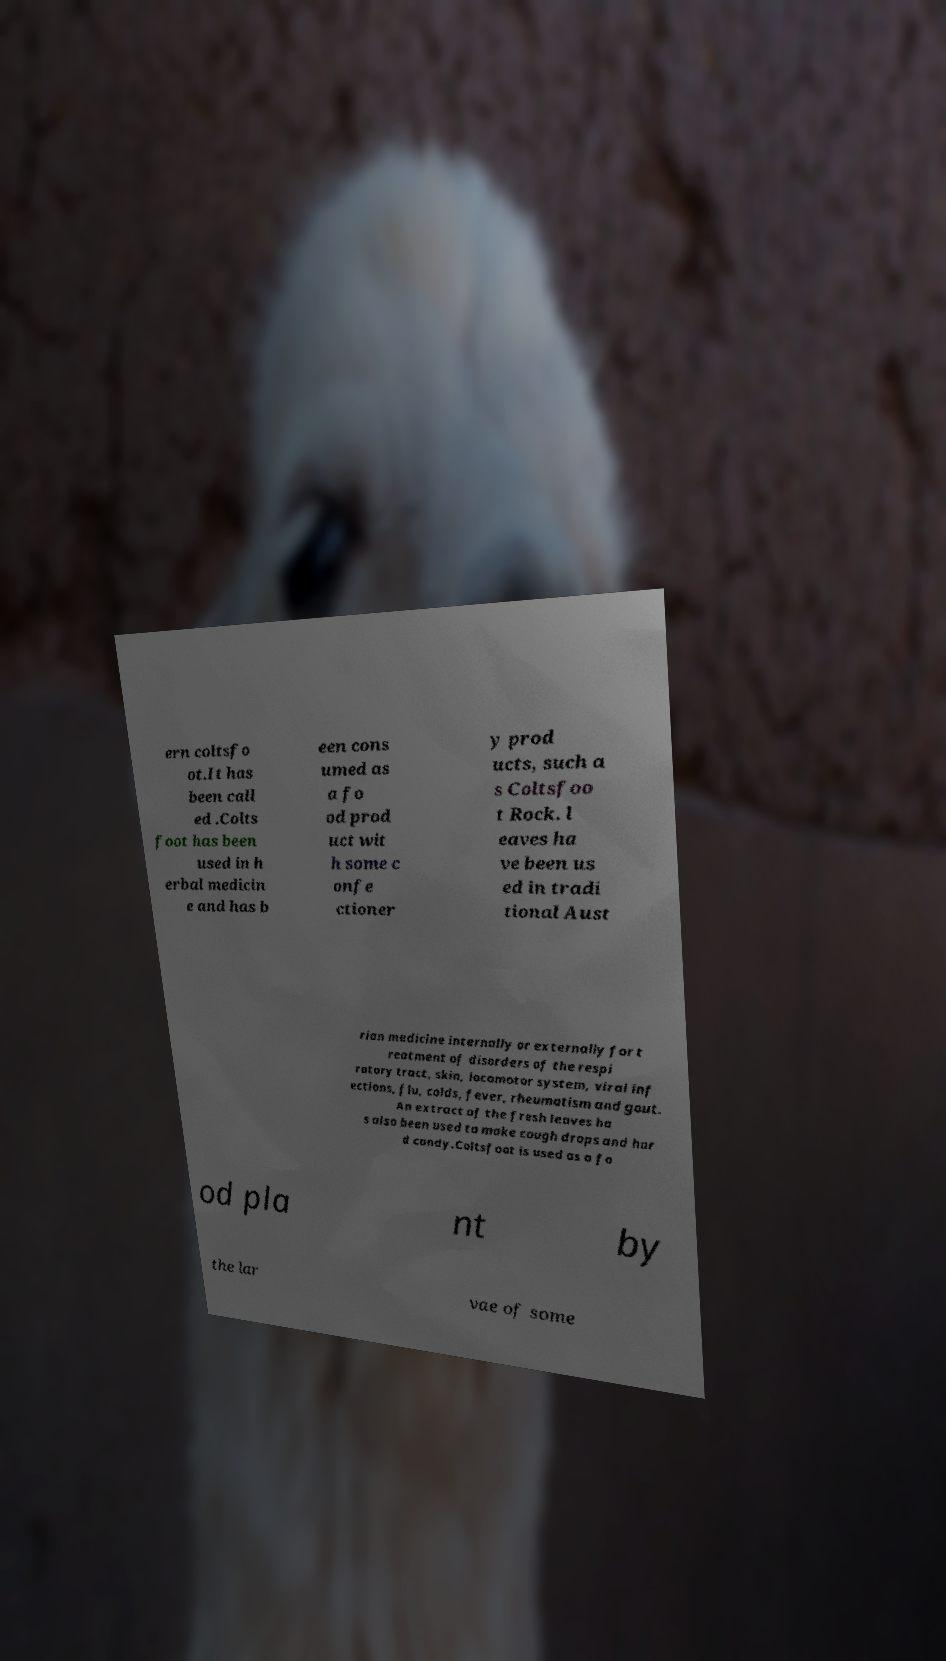Can you read and provide the text displayed in the image?This photo seems to have some interesting text. Can you extract and type it out for me? ern coltsfo ot.It has been call ed .Colts foot has been used in h erbal medicin e and has b een cons umed as a fo od prod uct wit h some c onfe ctioner y prod ucts, such a s Coltsfoo t Rock. l eaves ha ve been us ed in tradi tional Aust rian medicine internally or externally for t reatment of disorders of the respi ratory tract, skin, locomotor system, viral inf ections, flu, colds, fever, rheumatism and gout. An extract of the fresh leaves ha s also been used to make cough drops and har d candy.Coltsfoot is used as a fo od pla nt by the lar vae of some 